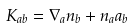<formula> <loc_0><loc_0><loc_500><loc_500>K _ { a b } = \nabla _ { a } n _ { b } + n _ { a } a _ { b }</formula> 